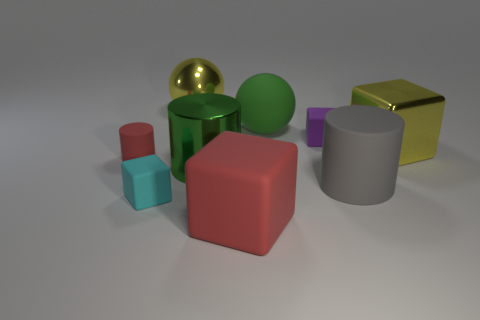Subtract all yellow metallic cubes. How many cubes are left? 3 Subtract all gray cylinders. How many cylinders are left? 2 Add 1 cyan objects. How many objects exist? 10 Subtract 3 cubes. How many cubes are left? 1 Subtract all gray cubes. Subtract all cyan cylinders. How many cubes are left? 4 Subtract all green spheres. How many green cylinders are left? 1 Subtract all small yellow cylinders. Subtract all tiny purple rubber things. How many objects are left? 8 Add 1 big matte spheres. How many big matte spheres are left? 2 Add 2 blue things. How many blue things exist? 2 Subtract 0 brown balls. How many objects are left? 9 